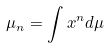<formula> <loc_0><loc_0><loc_500><loc_500>\mu _ { n } = \int x ^ { n } d \mu</formula> 